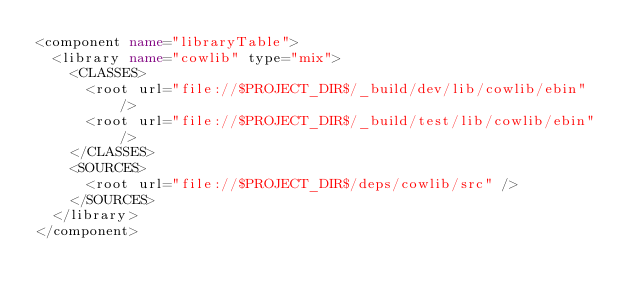Convert code to text. <code><loc_0><loc_0><loc_500><loc_500><_XML_><component name="libraryTable">
  <library name="cowlib" type="mix">
    <CLASSES>
      <root url="file://$PROJECT_DIR$/_build/dev/lib/cowlib/ebin" />
      <root url="file://$PROJECT_DIR$/_build/test/lib/cowlib/ebin" />
    </CLASSES>
    <SOURCES>
      <root url="file://$PROJECT_DIR$/deps/cowlib/src" />
    </SOURCES>
  </library>
</component></code> 